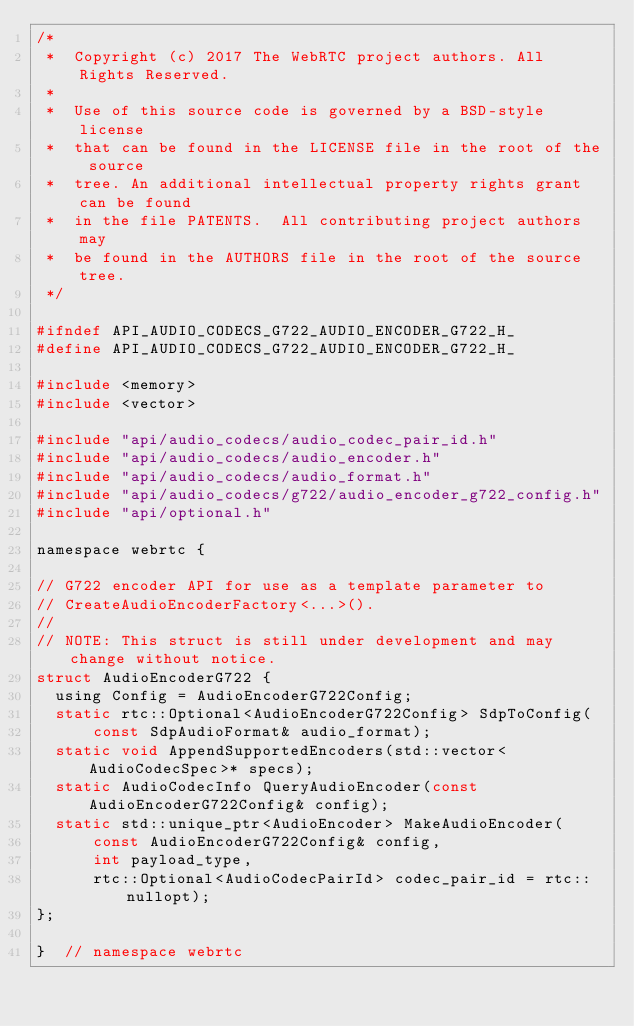Convert code to text. <code><loc_0><loc_0><loc_500><loc_500><_C_>/*
 *  Copyright (c) 2017 The WebRTC project authors. All Rights Reserved.
 *
 *  Use of this source code is governed by a BSD-style license
 *  that can be found in the LICENSE file in the root of the source
 *  tree. An additional intellectual property rights grant can be found
 *  in the file PATENTS.  All contributing project authors may
 *  be found in the AUTHORS file in the root of the source tree.
 */

#ifndef API_AUDIO_CODECS_G722_AUDIO_ENCODER_G722_H_
#define API_AUDIO_CODECS_G722_AUDIO_ENCODER_G722_H_

#include <memory>
#include <vector>

#include "api/audio_codecs/audio_codec_pair_id.h"
#include "api/audio_codecs/audio_encoder.h"
#include "api/audio_codecs/audio_format.h"
#include "api/audio_codecs/g722/audio_encoder_g722_config.h"
#include "api/optional.h"

namespace webrtc {

// G722 encoder API for use as a template parameter to
// CreateAudioEncoderFactory<...>().
//
// NOTE: This struct is still under development and may change without notice.
struct AudioEncoderG722 {
  using Config = AudioEncoderG722Config;
  static rtc::Optional<AudioEncoderG722Config> SdpToConfig(
      const SdpAudioFormat& audio_format);
  static void AppendSupportedEncoders(std::vector<AudioCodecSpec>* specs);
  static AudioCodecInfo QueryAudioEncoder(const AudioEncoderG722Config& config);
  static std::unique_ptr<AudioEncoder> MakeAudioEncoder(
      const AudioEncoderG722Config& config,
      int payload_type,
      rtc::Optional<AudioCodecPairId> codec_pair_id = rtc::nullopt);
};

}  // namespace webrtc
</code> 